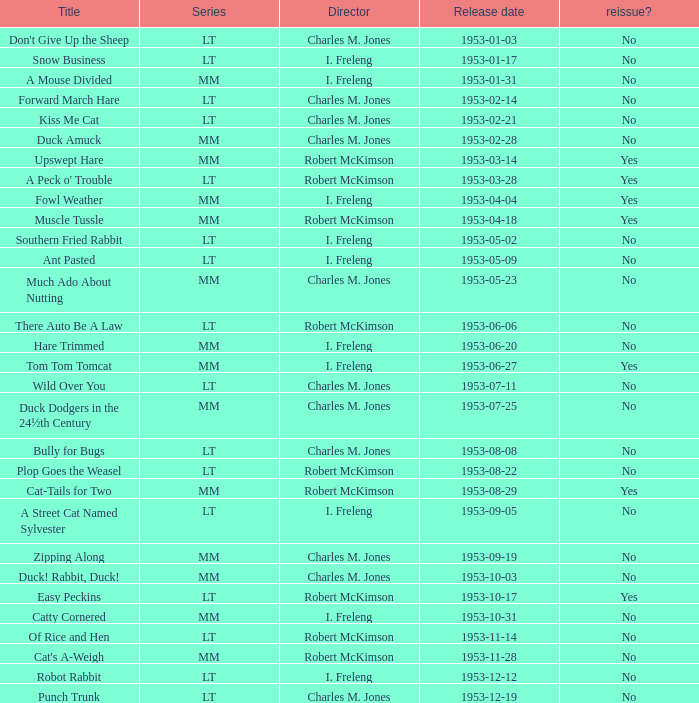What's the release date of Forward March Hare? 1953-02-14. 